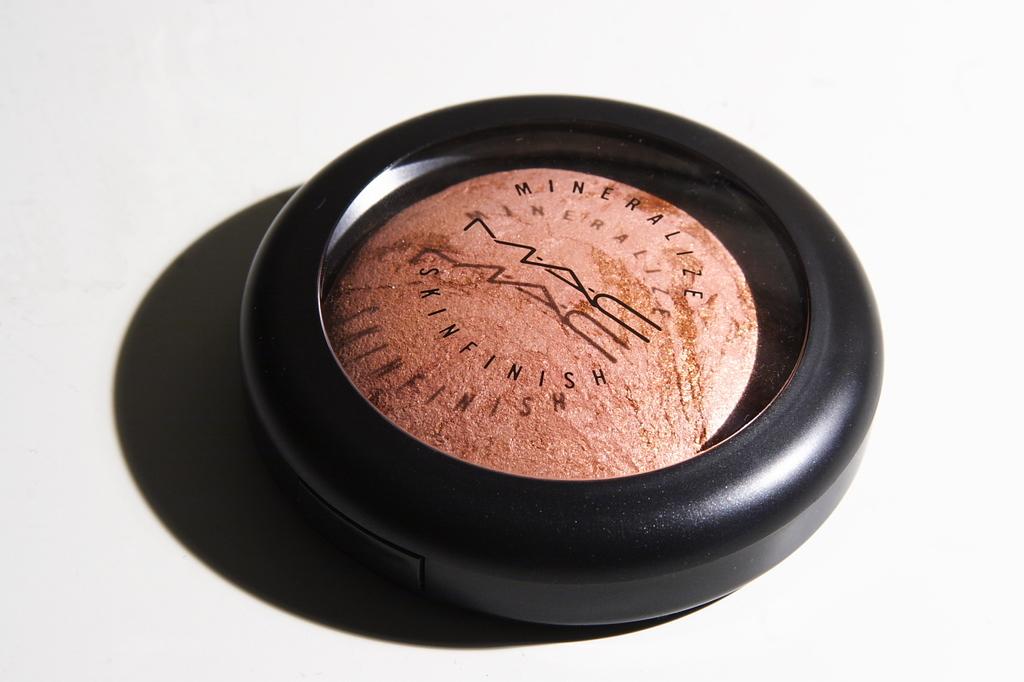What brand of makeup is this?
Offer a very short reply. Mac. 